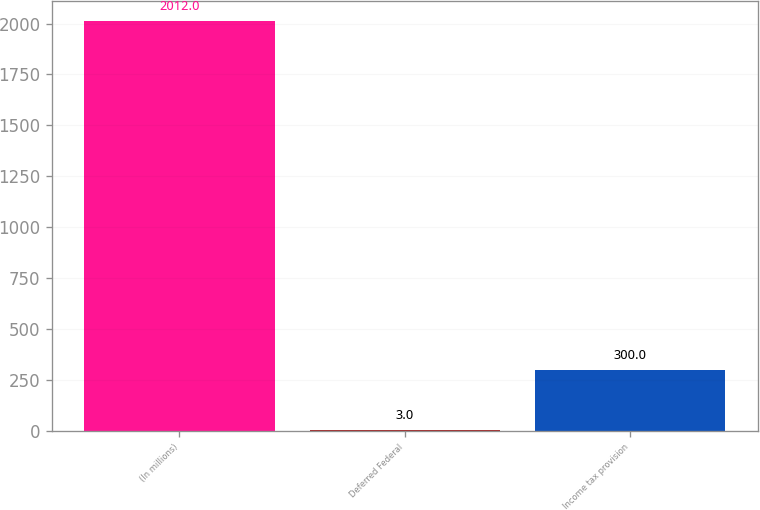Convert chart to OTSL. <chart><loc_0><loc_0><loc_500><loc_500><bar_chart><fcel>(In millions)<fcel>Deferred Federal<fcel>Income tax provision<nl><fcel>2012<fcel>3<fcel>300<nl></chart> 